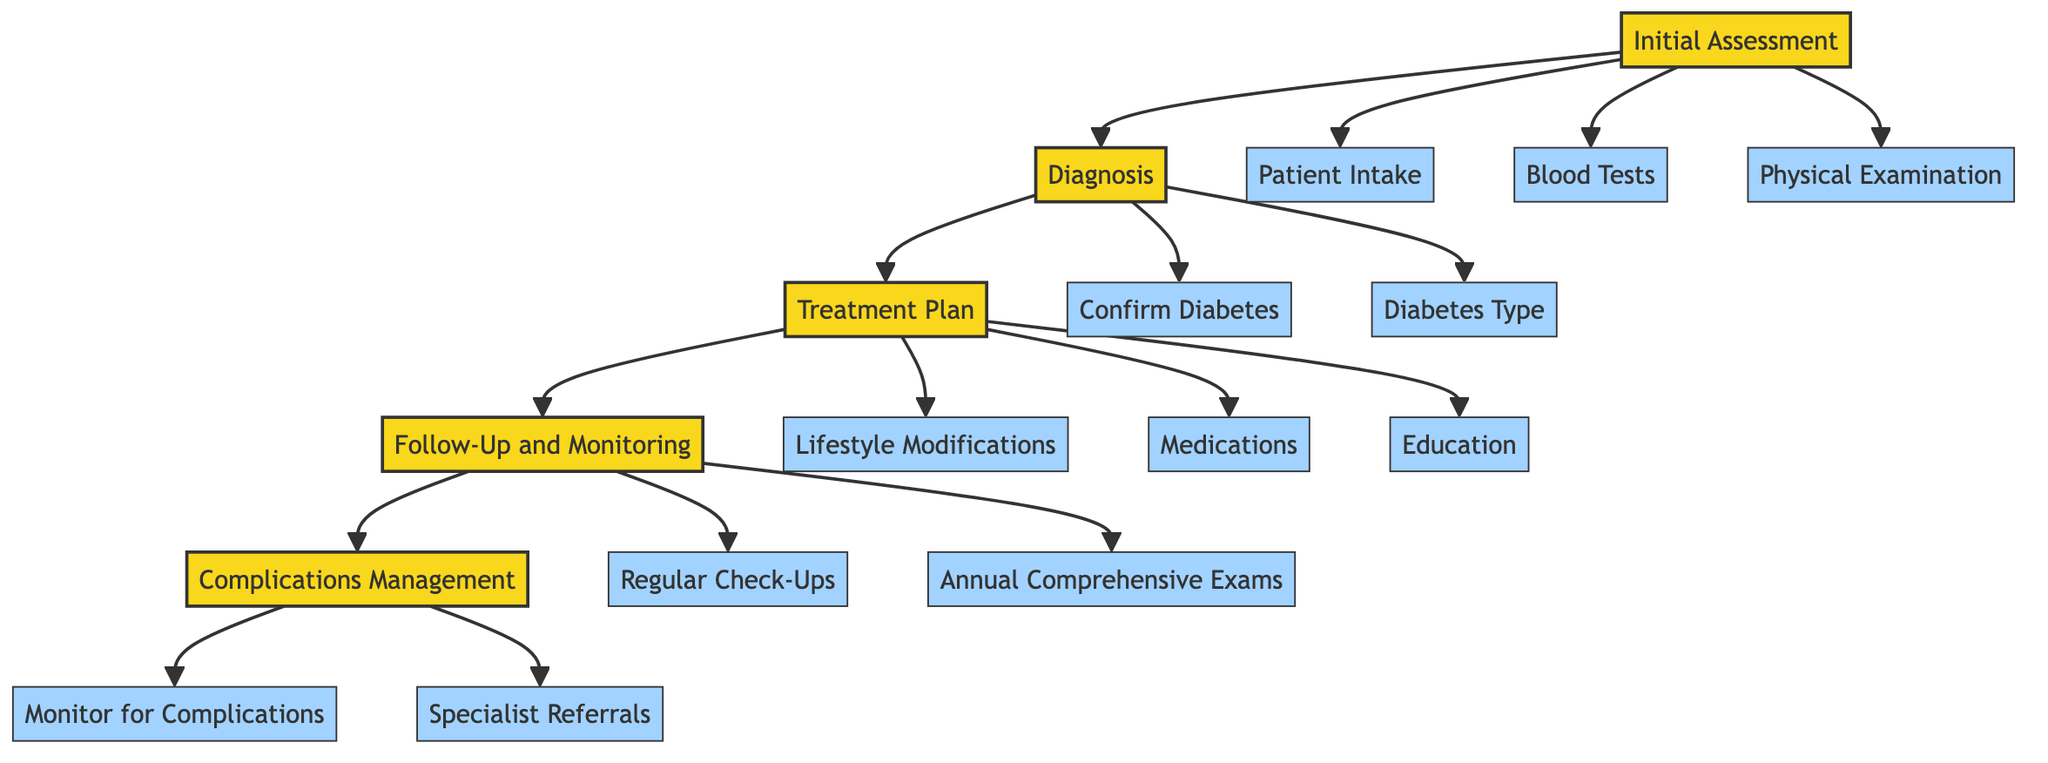What is the first step in the therapeutic protocol? The first step listed in the diagram is "Initial Assessment," which sets the foundation for the rest of the therapeutic protocol for managing diabetes.
Answer: Initial Assessment How many components are in the treatment plan step? The Treatment Plan step includes three components: Lifestyle Modifications, Medications, and Education. Thus, there are three distinct components under this step.
Answer: 3 What follows the diagnosis step? The diagram indicates that the next step after Diagnosis is "Treatment Plan." This shows the flow of the clinical pathway from one step to the next.
Answer: Treatment Plan Which component in the initial assessment checks for vital signs? Among the components of the Initial Assessment, "Physical Examination" includes checking vital signs, BMI, and performing a foot examination.
Answer: Physical Examination What are the two components of complications management? The Complications Management step encompasses two components: Monitor for Complications and Specialist Referrals, illustrating the focus on ongoing care for potential complications.
Answer: Monitor for Complications, Specialist Referrals In which step would you find recommendations on exercise? Recommendations on exercise are part of "Lifestyle Modifications," which is a component of the Treatment Plan step, indicating that lifestyle changes are addressed at this stage.
Answer: Lifestyle Modifications How many follow-up components are listed? There are two components listed under the Follow-Up and Monitoring step: Regular Check-Ups and Annual Comprehensive Exams, indicating the importance of consistent monitoring and evaluation.
Answer: 2 Which type of diabetes is determined during the diagnosis step? The Diagnosis step specifies that one must determine if the diabetes is Type 1, Type 2, or gestational diabetes, highlighting the need for accurate classification during diagnosis.
Answer: Type 1, Type 2, or gestational diabetes Which component follows "Patient Intake" in the initial assessment? In the Initial Assessment step, "Blood Tests" follows "Patient Intake," indicating that after gathering personal history, laboratory tests are next performed.
Answer: Blood Tests 